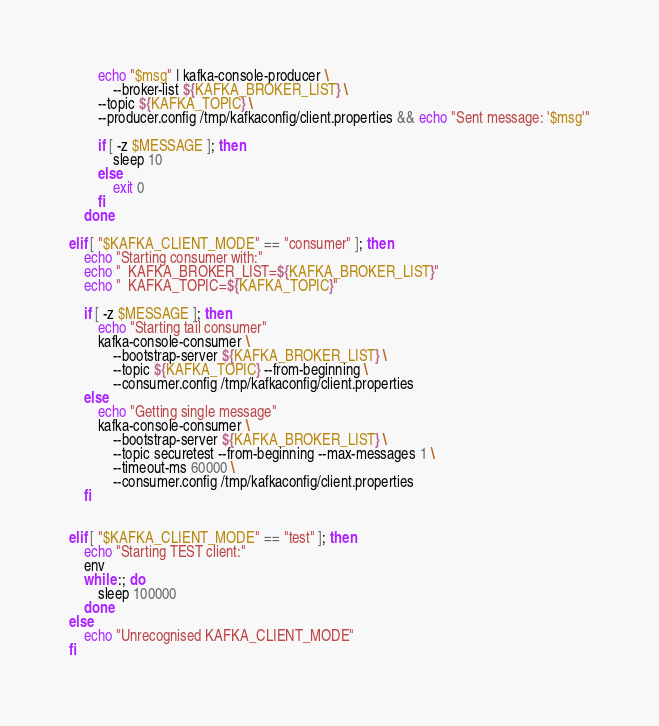Convert code to text. <code><loc_0><loc_0><loc_500><loc_500><_Bash_>
        echo "$msg" | kafka-console-producer \
            --broker-list ${KAFKA_BROKER_LIST} \
        --topic ${KAFKA_TOPIC} \
        --producer.config /tmp/kafkaconfig/client.properties && echo "Sent message: '$msg'"

        if [ -z $MESSAGE ]; then
            sleep 10
        else
            exit 0
        fi
    done

elif [ "$KAFKA_CLIENT_MODE" == "consumer" ]; then
    echo "Starting consumer with:"
    echo "  KAFKA_BROKER_LIST=${KAFKA_BROKER_LIST}"
    echo "  KAFKA_TOPIC=${KAFKA_TOPIC}"

    if [ -z $MESSAGE ]; then
        echo "Starting tail consumer"
        kafka-console-consumer \
            --bootstrap-server ${KAFKA_BROKER_LIST} \
            --topic ${KAFKA_TOPIC} --from-beginning \
            --consumer.config /tmp/kafkaconfig/client.properties
    else
        echo "Getting single message"
        kafka-console-consumer \
            --bootstrap-server ${KAFKA_BROKER_LIST} \
            --topic securetest --from-beginning --max-messages 1 \
            --timeout-ms 60000 \
            --consumer.config /tmp/kafkaconfig/client.properties
    fi


elif [ "$KAFKA_CLIENT_MODE" == "test" ]; then
    echo "Starting TEST client:"
    env
    while :; do
        sleep 100000
    done
else
    echo "Unrecognised KAFKA_CLIENT_MODE"
fi
</code> 